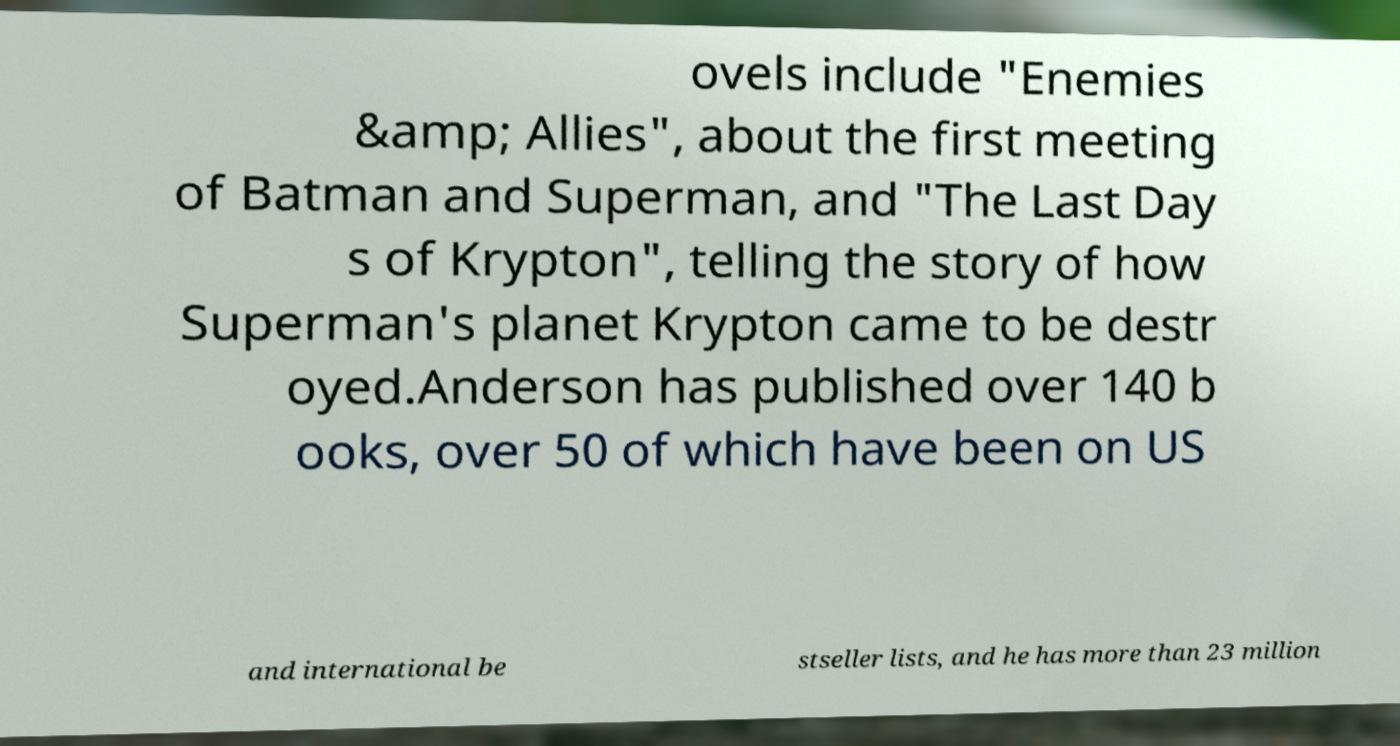Could you extract and type out the text from this image? ovels include "Enemies &amp; Allies", about the first meeting of Batman and Superman, and "The Last Day s of Krypton", telling the story of how Superman's planet Krypton came to be destr oyed.Anderson has published over 140 b ooks, over 50 of which have been on US and international be stseller lists, and he has more than 23 million 